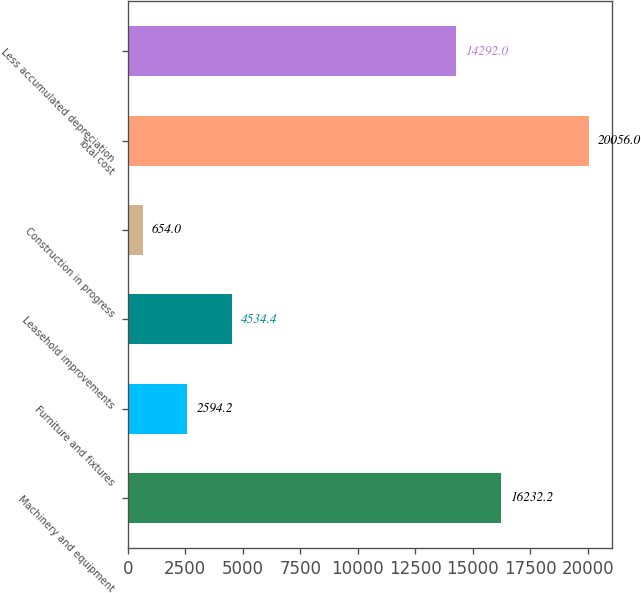<chart> <loc_0><loc_0><loc_500><loc_500><bar_chart><fcel>Machinery and equipment<fcel>Furniture and fixtures<fcel>Leasehold improvements<fcel>Construction in progress<fcel>Total cost<fcel>Less accumulated depreciation<nl><fcel>16232.2<fcel>2594.2<fcel>4534.4<fcel>654<fcel>20056<fcel>14292<nl></chart> 